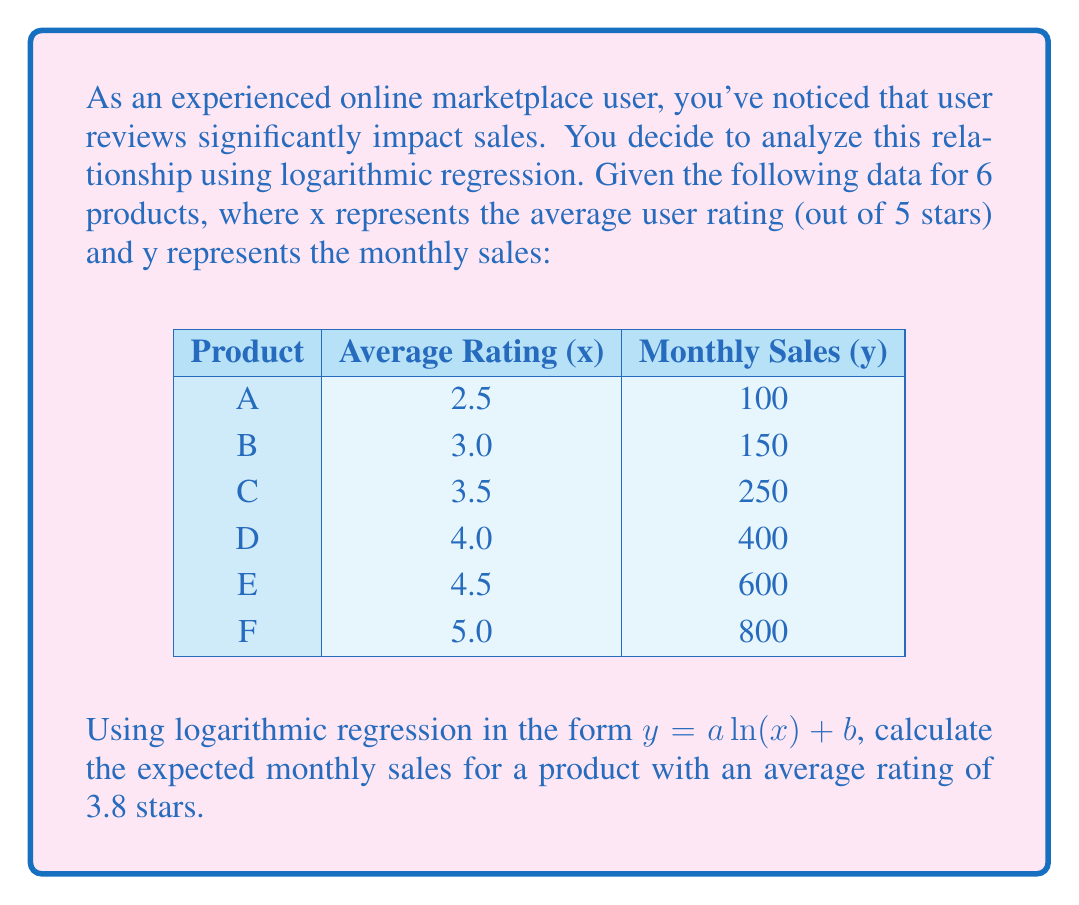Give your solution to this math problem. To solve this problem, we'll use logarithmic regression to find the best-fit curve, then use the resulting equation to predict sales for a 3.8-star rated product.

Step 1: Set up the equations for logarithmic regression.
We use the formula $y = a \ln(x) + b$, where:
$a = \frac{n\sum(\ln(x)y) - \sum(\ln(x))\sum(y)}{n\sum(\ln(x))^2 - (\sum(\ln(x)))^2}$
$b = \frac{\sum(y)}{n} - a\frac{\sum(\ln(x))}{n}$

Step 2: Calculate necessary sums.
$\sum(\ln(x)) = \ln(2.5) + \ln(3.0) + \ln(3.5) + \ln(4.0) + \ln(4.5) + \ln(5.0) = 7.3778$
$\sum(y) = 100 + 150 + 250 + 400 + 600 + 800 = 2300$
$\sum(\ln(x)y) = 0.9163 \cdot 100 + 1.0986 \cdot 150 + 1.2528 \cdot 250 + 1.3863 \cdot 400 + 1.5041 \cdot 600 + 1.6094 \cdot 800 = 3191.5825$
$\sum(\ln(x))^2 = 0.9163^2 + 1.0986^2 + 1.2528^2 + 1.3863^2 + 1.5041^2 + 1.6094^2 = 9.1339$

Step 3: Calculate a and b.
$a = \frac{6 \cdot 3191.5825 - 7.3778 \cdot 2300}{6 \cdot 9.1339 - 7.3778^2} = 1036.0534$
$b = \frac{2300}{6} - 1036.0534 \cdot \frac{7.3778}{6} = -935.7378$

Step 4: Form the regression equation.
$y = 1036.0534 \ln(x) - 935.7378$

Step 5: Calculate expected sales for a 3.8-star rated product.
$y = 1036.0534 \ln(3.8) - 935.7378 = 345.7656$

Therefore, the expected monthly sales for a product with an average rating of 3.8 stars is approximately 346 units.
Answer: 346 units 